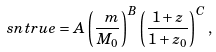Convert formula to latex. <formula><loc_0><loc_0><loc_500><loc_500>\ s n t r u e = A \left ( \frac { \ m } { M _ { 0 } } \right ) ^ { B } \left ( \frac { 1 + z } { 1 + z _ { 0 } } \right ) ^ { C } ,</formula> 